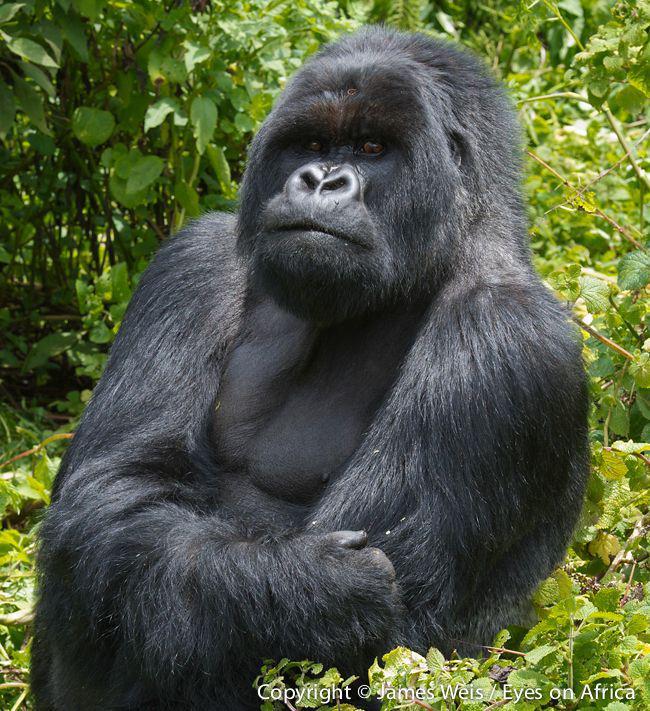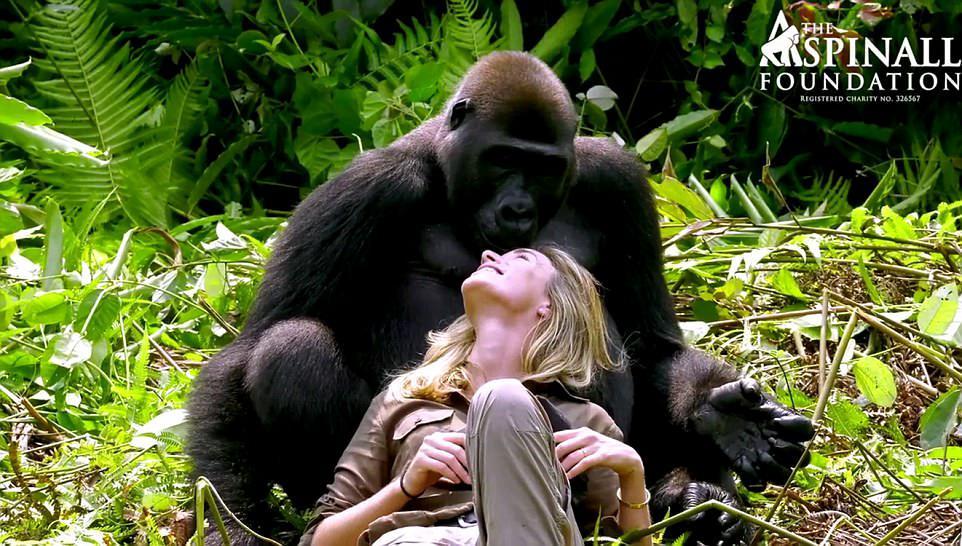The first image is the image on the left, the second image is the image on the right. For the images shown, is this caption "An image features one person gazing into the face of a large ape." true? Answer yes or no. Yes. The first image is the image on the left, the second image is the image on the right. Examine the images to the left and right. Is the description "The right photo shows an adult gorilla interacting with a human being" accurate? Answer yes or no. Yes. 